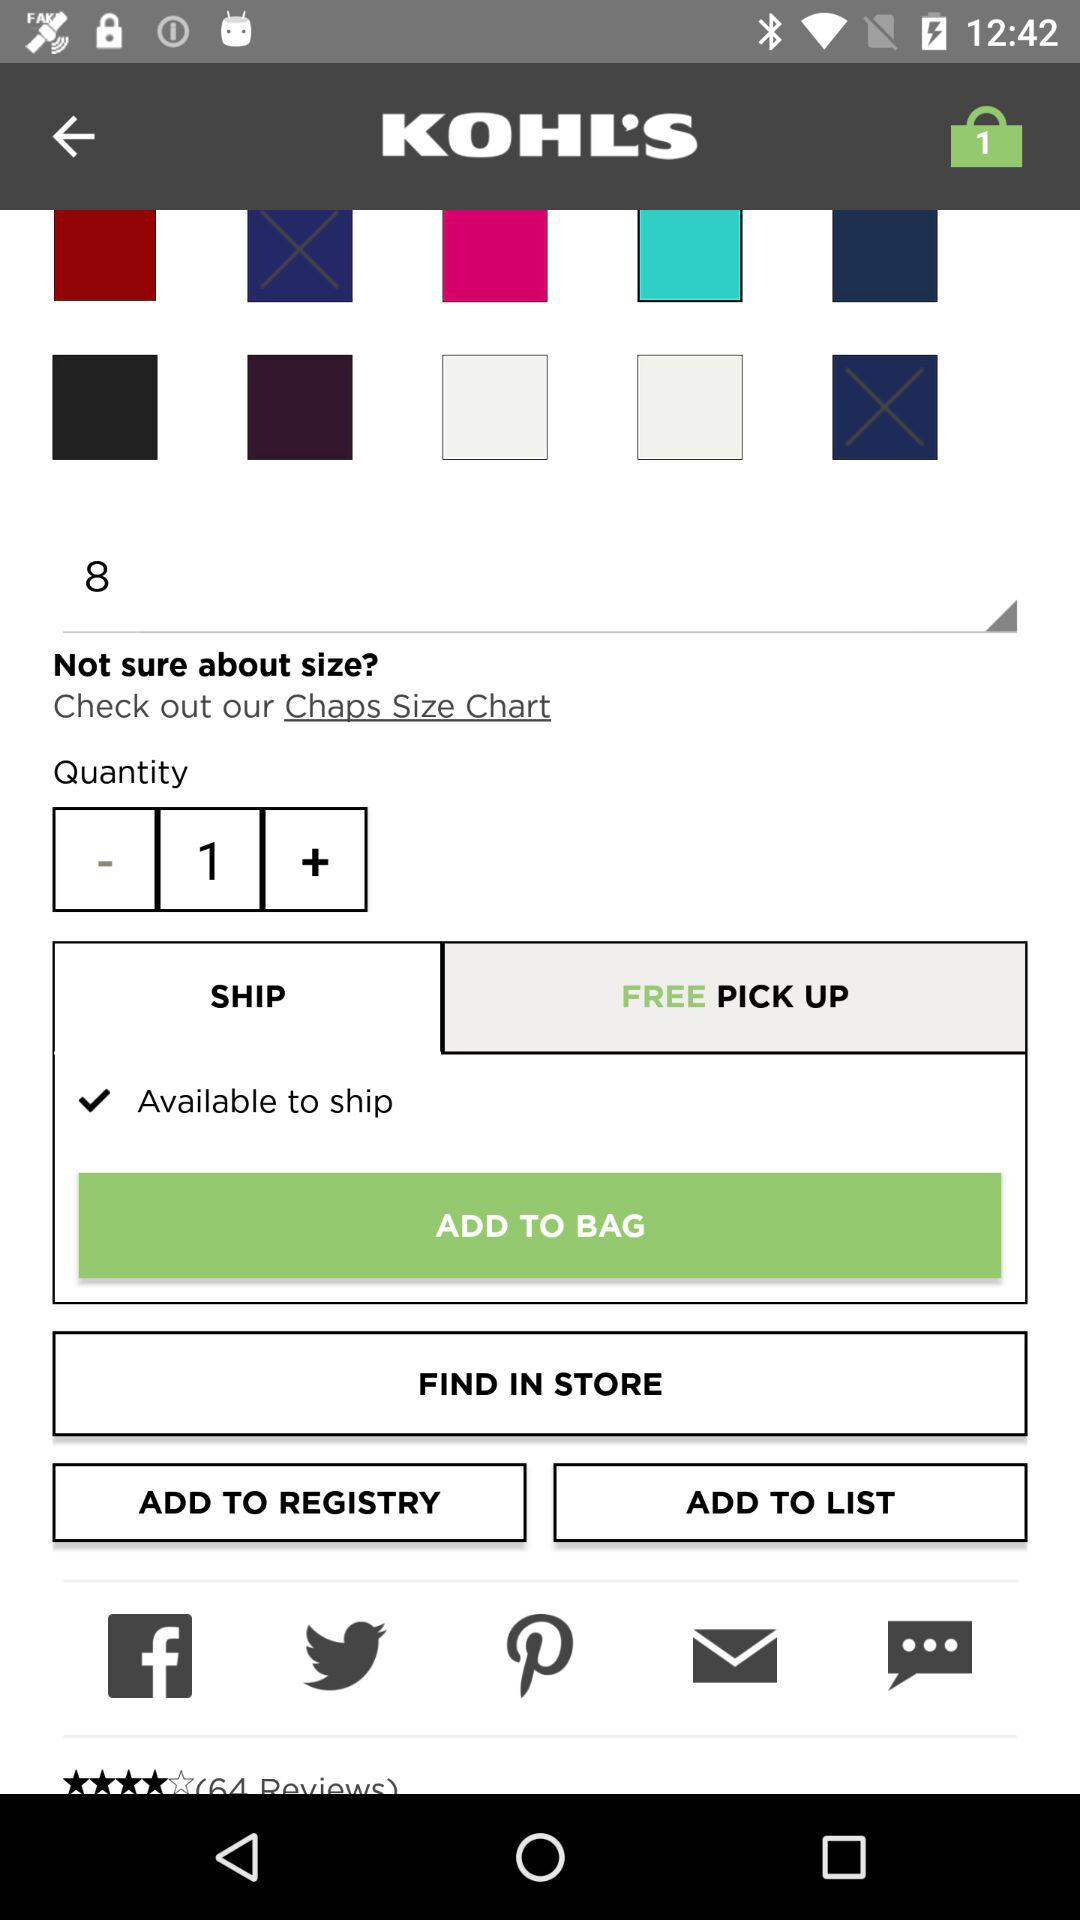How many reviews are there?
When the provided information is insufficient, respond with <no answer>. <no answer> 